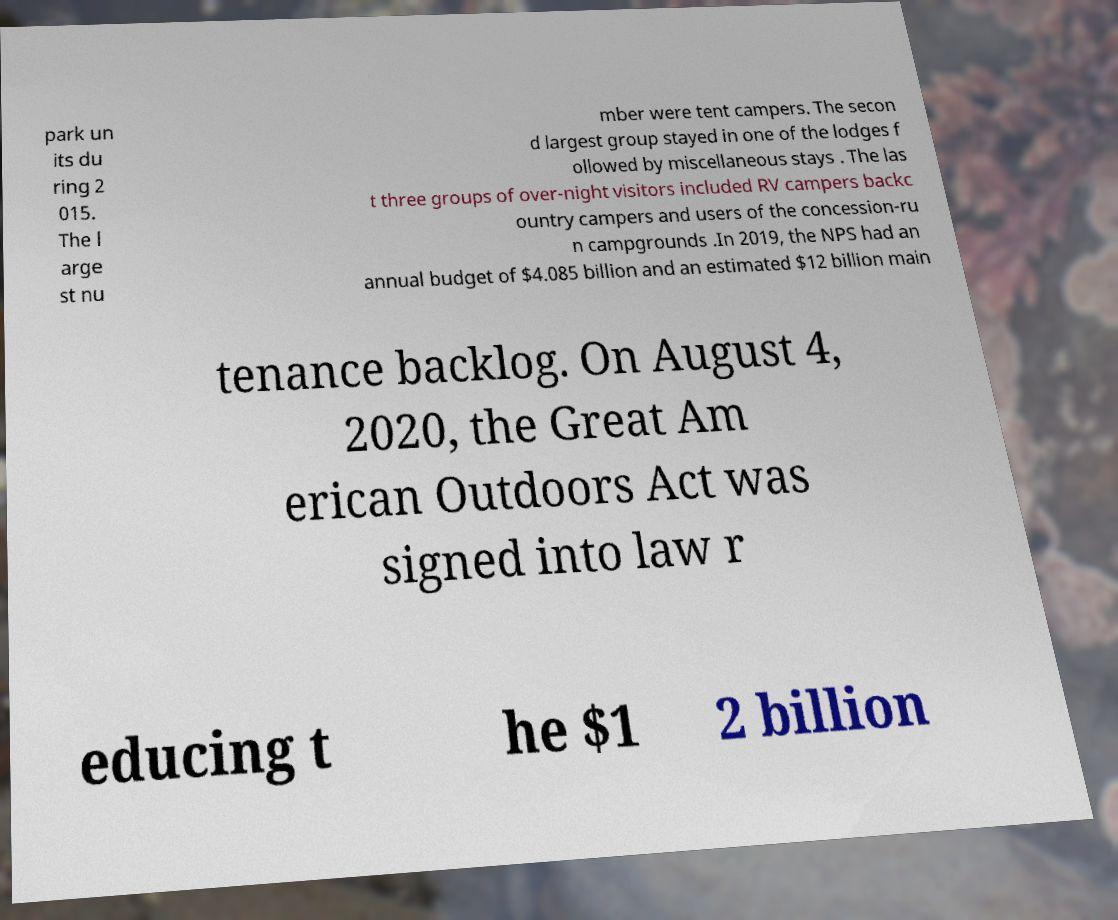Please read and relay the text visible in this image. What does it say? park un its du ring 2 015. The l arge st nu mber were tent campers. The secon d largest group stayed in one of the lodges f ollowed by miscellaneous stays . The las t three groups of over-night visitors included RV campers backc ountry campers and users of the concession-ru n campgrounds .In 2019, the NPS had an annual budget of $4.085 billion and an estimated $12 billion main tenance backlog. On August 4, 2020, the Great Am erican Outdoors Act was signed into law r educing t he $1 2 billion 